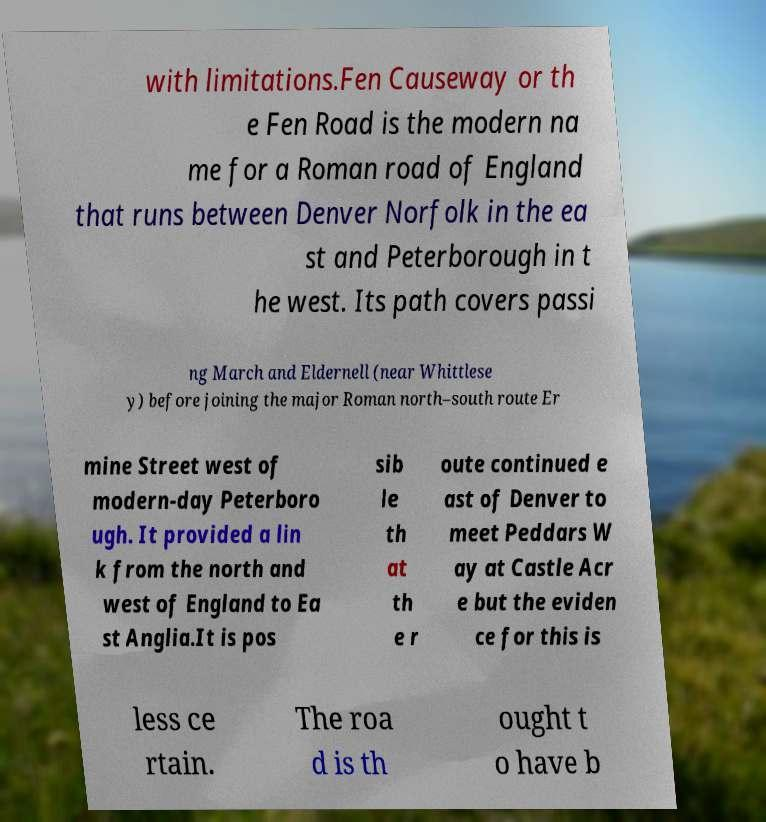Please identify and transcribe the text found in this image. with limitations.Fen Causeway or th e Fen Road is the modern na me for a Roman road of England that runs between Denver Norfolk in the ea st and Peterborough in t he west. Its path covers passi ng March and Eldernell (near Whittlese y) before joining the major Roman north–south route Er mine Street west of modern-day Peterboro ugh. It provided a lin k from the north and west of England to Ea st Anglia.It is pos sib le th at th e r oute continued e ast of Denver to meet Peddars W ay at Castle Acr e but the eviden ce for this is less ce rtain. The roa d is th ought t o have b 